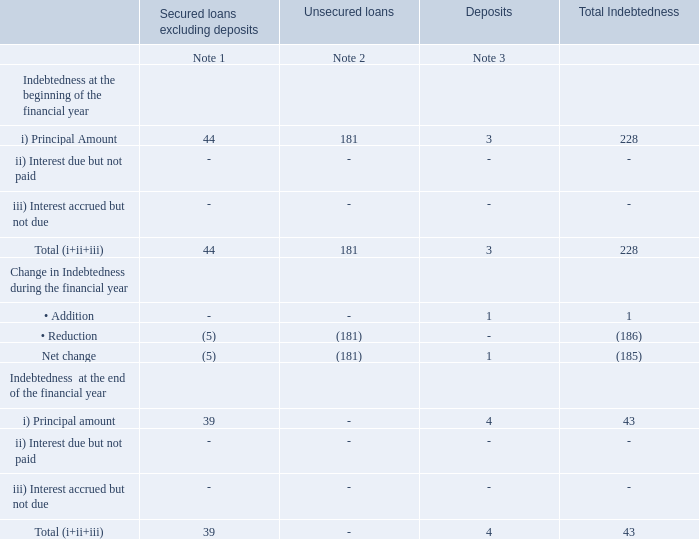V. INDEBTEDNESS
Indebtedness of the Company including interest outstanding/accrued but not due for payment
Notes:
1. Secured loans excluding deposits of `39 crore as at March 31, 2019, represents obligations under finance lease including current portion of obligations.
2. Opening balance as at April 1, 2018, of unsecured loans represent bank overdraft of `181 crore.
3. Deposits represent amounts received from lessee for the premises given on sub-lease and from vendors for contracts to be executed.
What was the value of deposits as at March 31, 2019? `39 crore. What are deposits? Deposits represent amounts received from lessee for the premises given on sub-lease and from vendors for contracts to be executed. What is the value of the bank overdraft as at April 1, 2018? `181 crore. At the beginning of the financial year, what percentage of total indebtedness is made up of deposits?
Answer scale should be: percent. 3/228 
Answer: 1.32. What is the percentage change in indebtedness at the beginning and the end of the financial year?
Answer scale should be: percent. 185/228 
Answer: 81.14. At the end of the financial year, what percentage of total indebtedness is made up of secured loans excluding deposits?
Answer scale should be: percent. 39/43 
Answer: 90.7. 